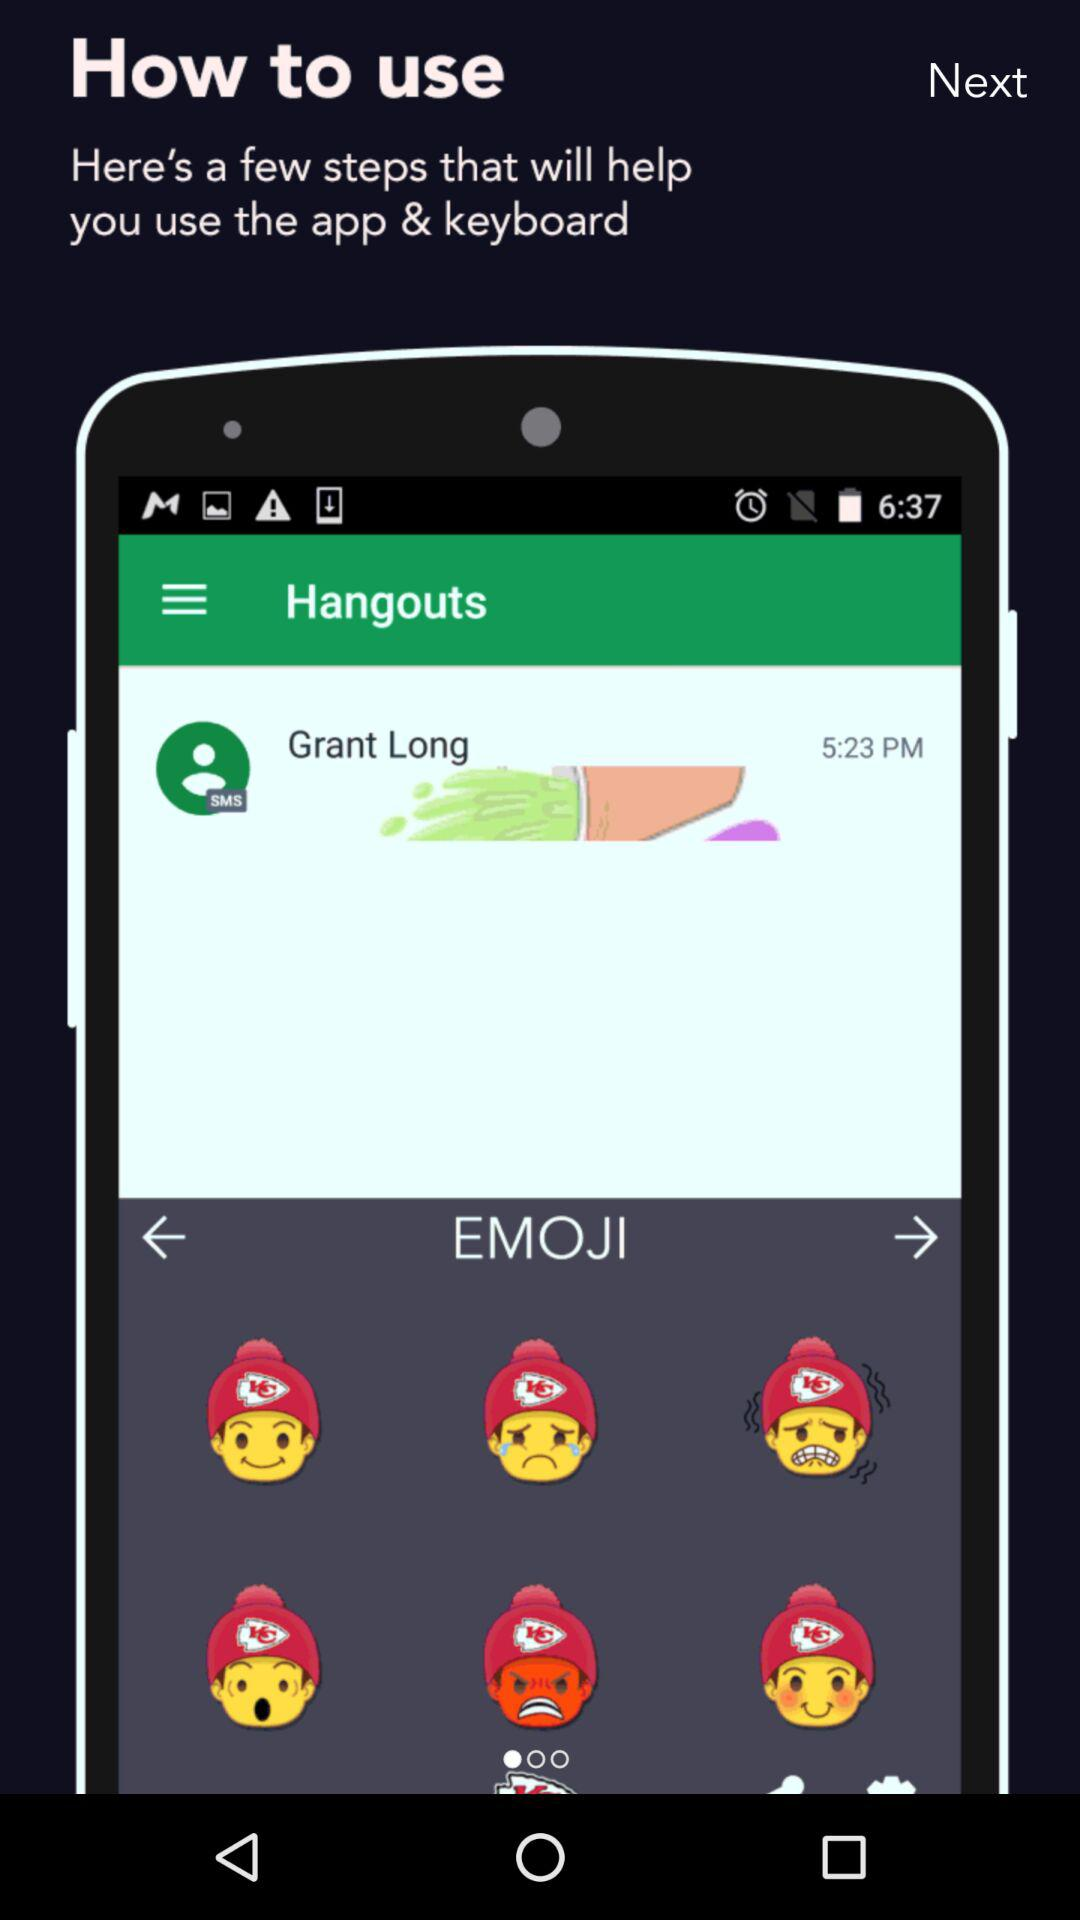What is the time? The times are 6:37 and 5:23 PM. 